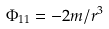<formula> <loc_0><loc_0><loc_500><loc_500>\Phi _ { 1 1 } = - 2 m / r ^ { 3 }</formula> 